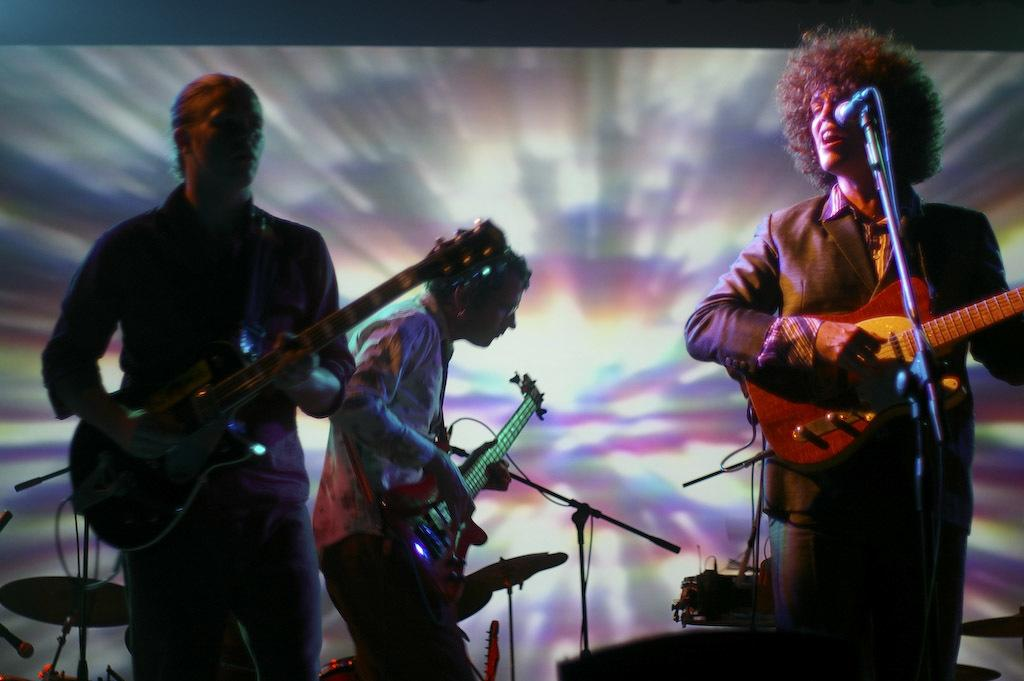How many men are in the image? There are three men in the image. What are the men doing in the image? Each man is holding a guitar and playing it. Is there anyone else in the image besides the men? Yes, there is a person singing into a microphone. What musical instruments can be seen in the background? There is a piano and drums in the background. What type of coal is being used to fuel the fire during the feast in the image? There is no mention of coal or a feast in the image; it features three men playing guitars, a person singing, and musical instruments in the background. 